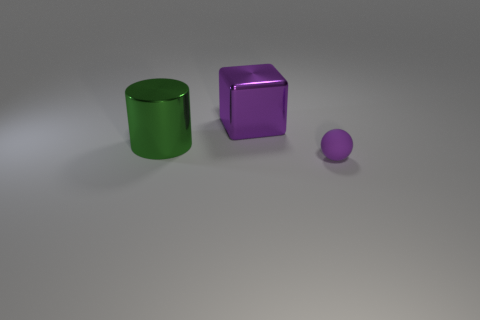Add 2 big green matte cylinders. How many objects exist? 5 Subtract all balls. How many objects are left? 2 Subtract all big purple cylinders. Subtract all green things. How many objects are left? 2 Add 3 purple objects. How many purple objects are left? 5 Add 2 gray blocks. How many gray blocks exist? 2 Subtract 0 yellow balls. How many objects are left? 3 